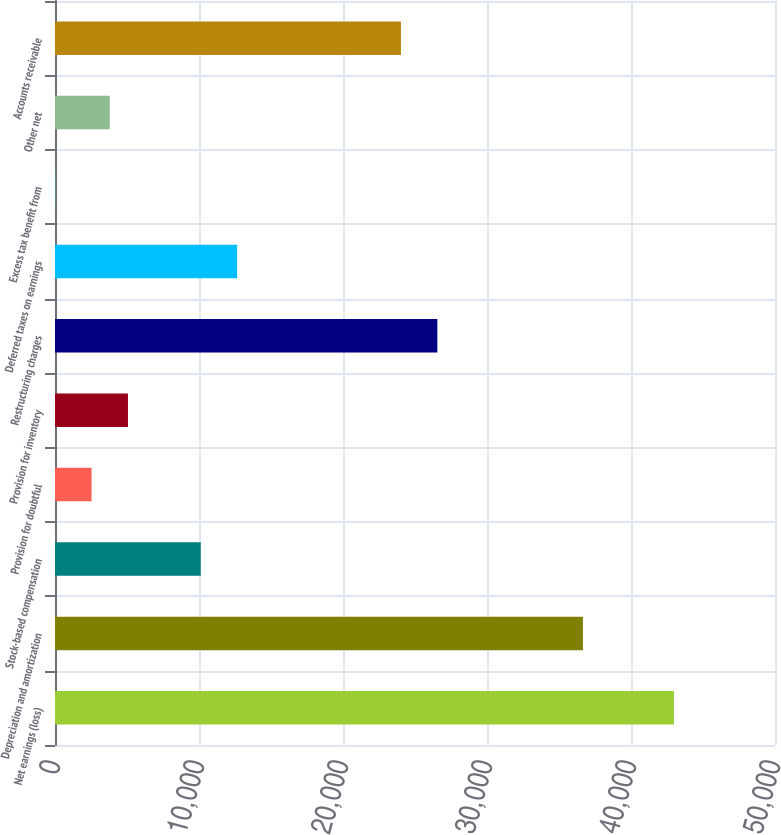Convert chart to OTSL. <chart><loc_0><loc_0><loc_500><loc_500><bar_chart><fcel>Net earnings (loss)<fcel>Depreciation and amortization<fcel>Stock-based compensation<fcel>Provision for doubtful<fcel>Provision for inventory<fcel>Restructuring charges<fcel>Deferred taxes on earnings<fcel>Excess tax benefit from<fcel>Other net<fcel>Accounts receivable<nl><fcel>42981.2<fcel>36662.2<fcel>10122.4<fcel>2539.6<fcel>5067.2<fcel>26551.8<fcel>12650<fcel>12<fcel>3803.4<fcel>24024.2<nl></chart> 